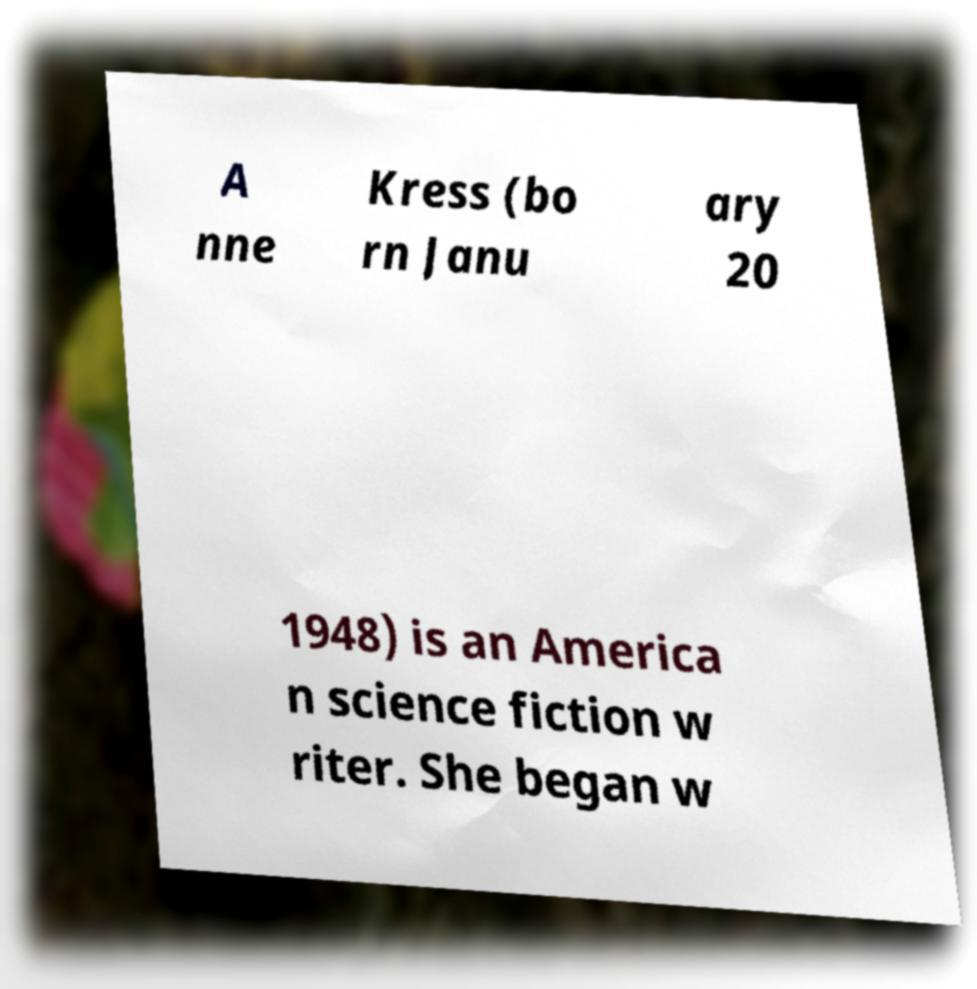There's text embedded in this image that I need extracted. Can you transcribe it verbatim? A nne Kress (bo rn Janu ary 20 1948) is an America n science fiction w riter. She began w 